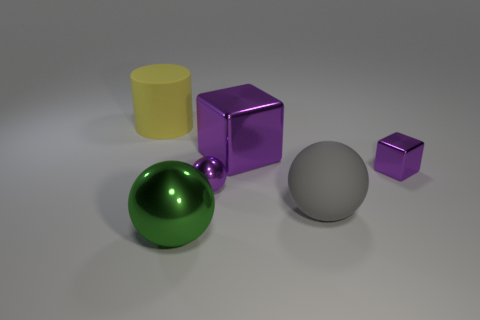What can you infer about the material of the objects based on their appearance? The objects appear to have different materials based on their surfaces' reactions to light. The yellow cylinder has a matte finish, suggesting it could be made of plastic or painted wood. The purple cubes are reflective, which might indicate a metallic or glossy plastic material. The green sphere is highly reflective, which is characteristic of polished metal or glass. The neutral gray sphere and smaller purple cube look similar to the larger cube, implying they share its material properties. 